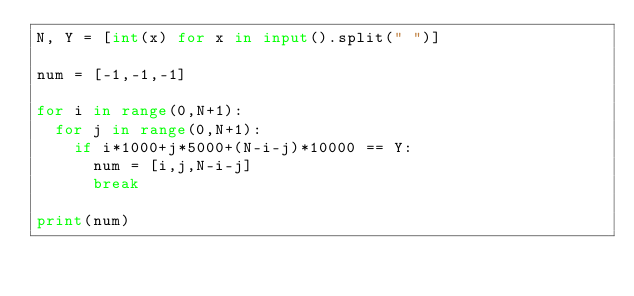<code> <loc_0><loc_0><loc_500><loc_500><_Python_>N, Y = [int(x) for x in input().split(" ")]

num = [-1,-1,-1]

for i in range(0,N+1):
  for j in range(0,N+1):
    if i*1000+j*5000+(N-i-j)*10000 == Y:
      num = [i,j,N-i-j]
      break

print(num)</code> 